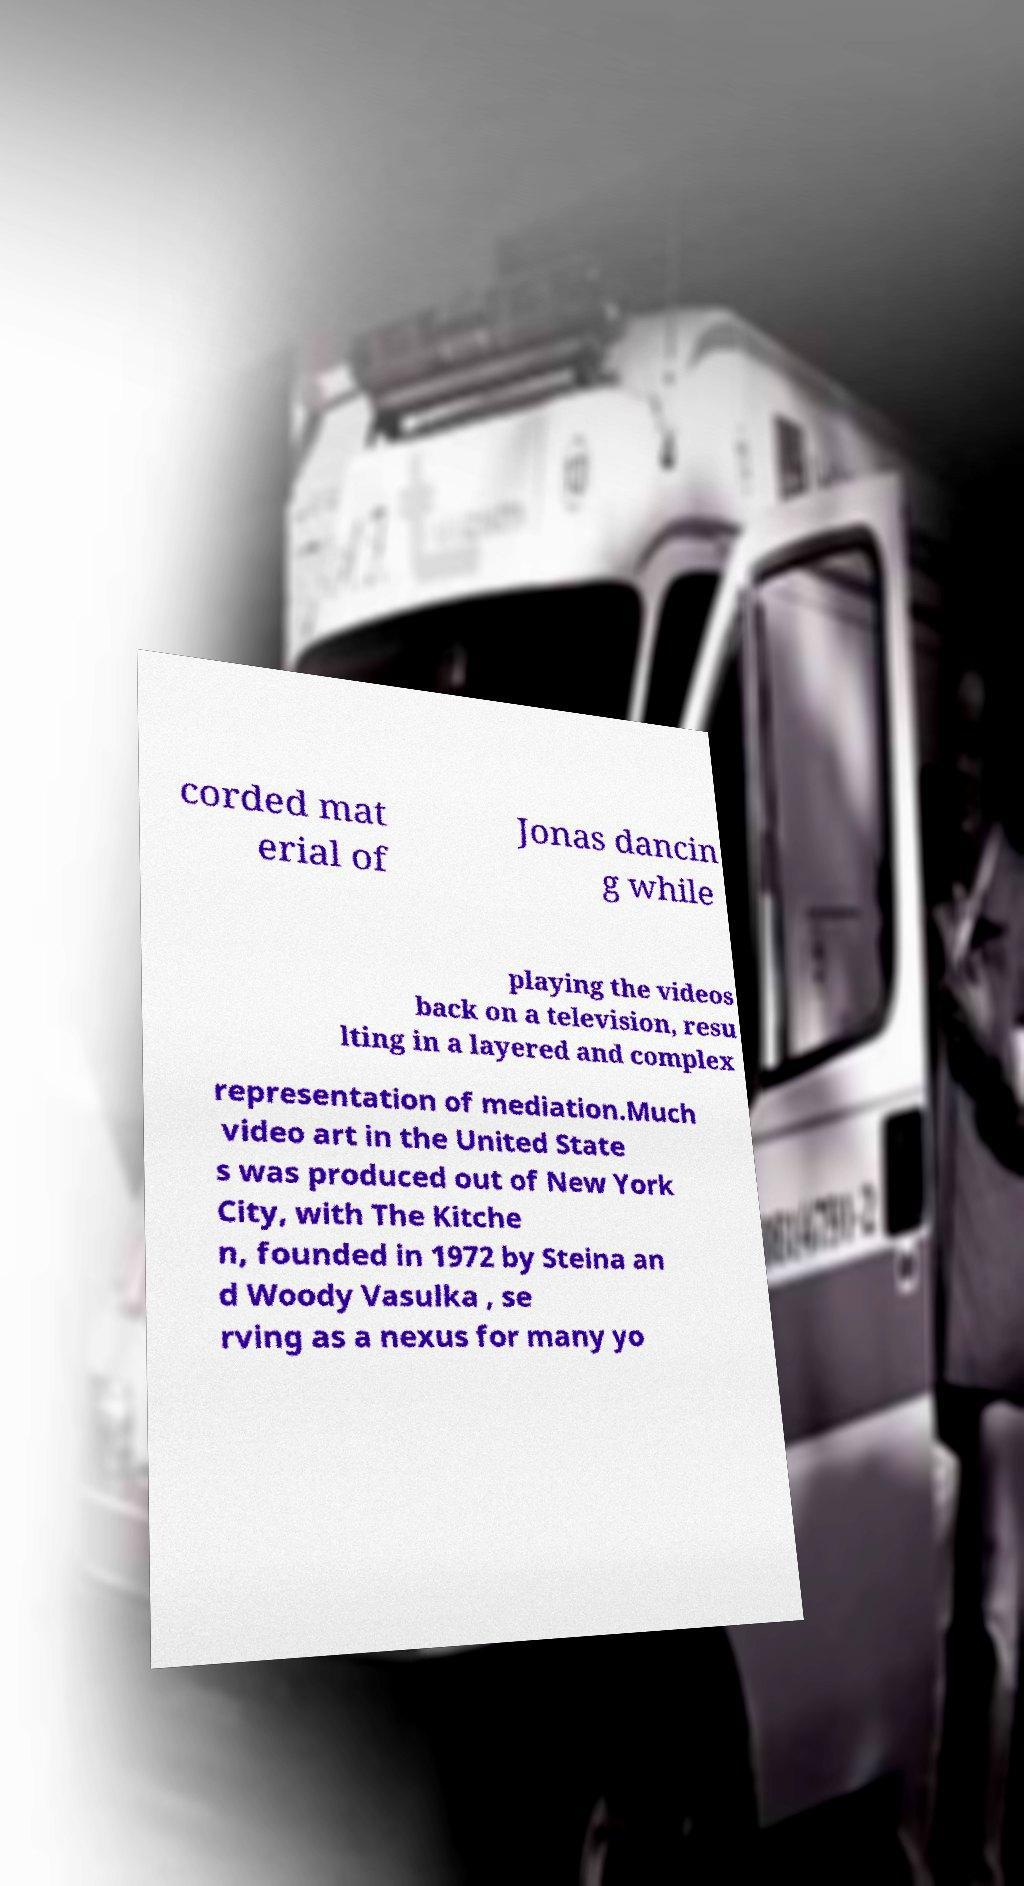For documentation purposes, I need the text within this image transcribed. Could you provide that? corded mat erial of Jonas dancin g while playing the videos back on a television, resu lting in a layered and complex representation of mediation.Much video art in the United State s was produced out of New York City, with The Kitche n, founded in 1972 by Steina an d Woody Vasulka , se rving as a nexus for many yo 